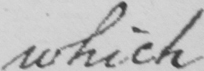Please provide the text content of this handwritten line. which 